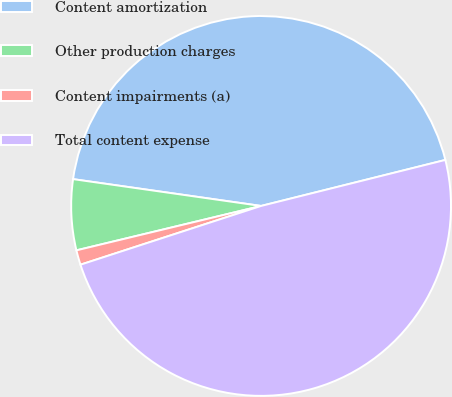<chart> <loc_0><loc_0><loc_500><loc_500><pie_chart><fcel>Content amortization<fcel>Other production charges<fcel>Content impairments (a)<fcel>Total content expense<nl><fcel>43.85%<fcel>6.01%<fcel>1.25%<fcel>48.89%<nl></chart> 